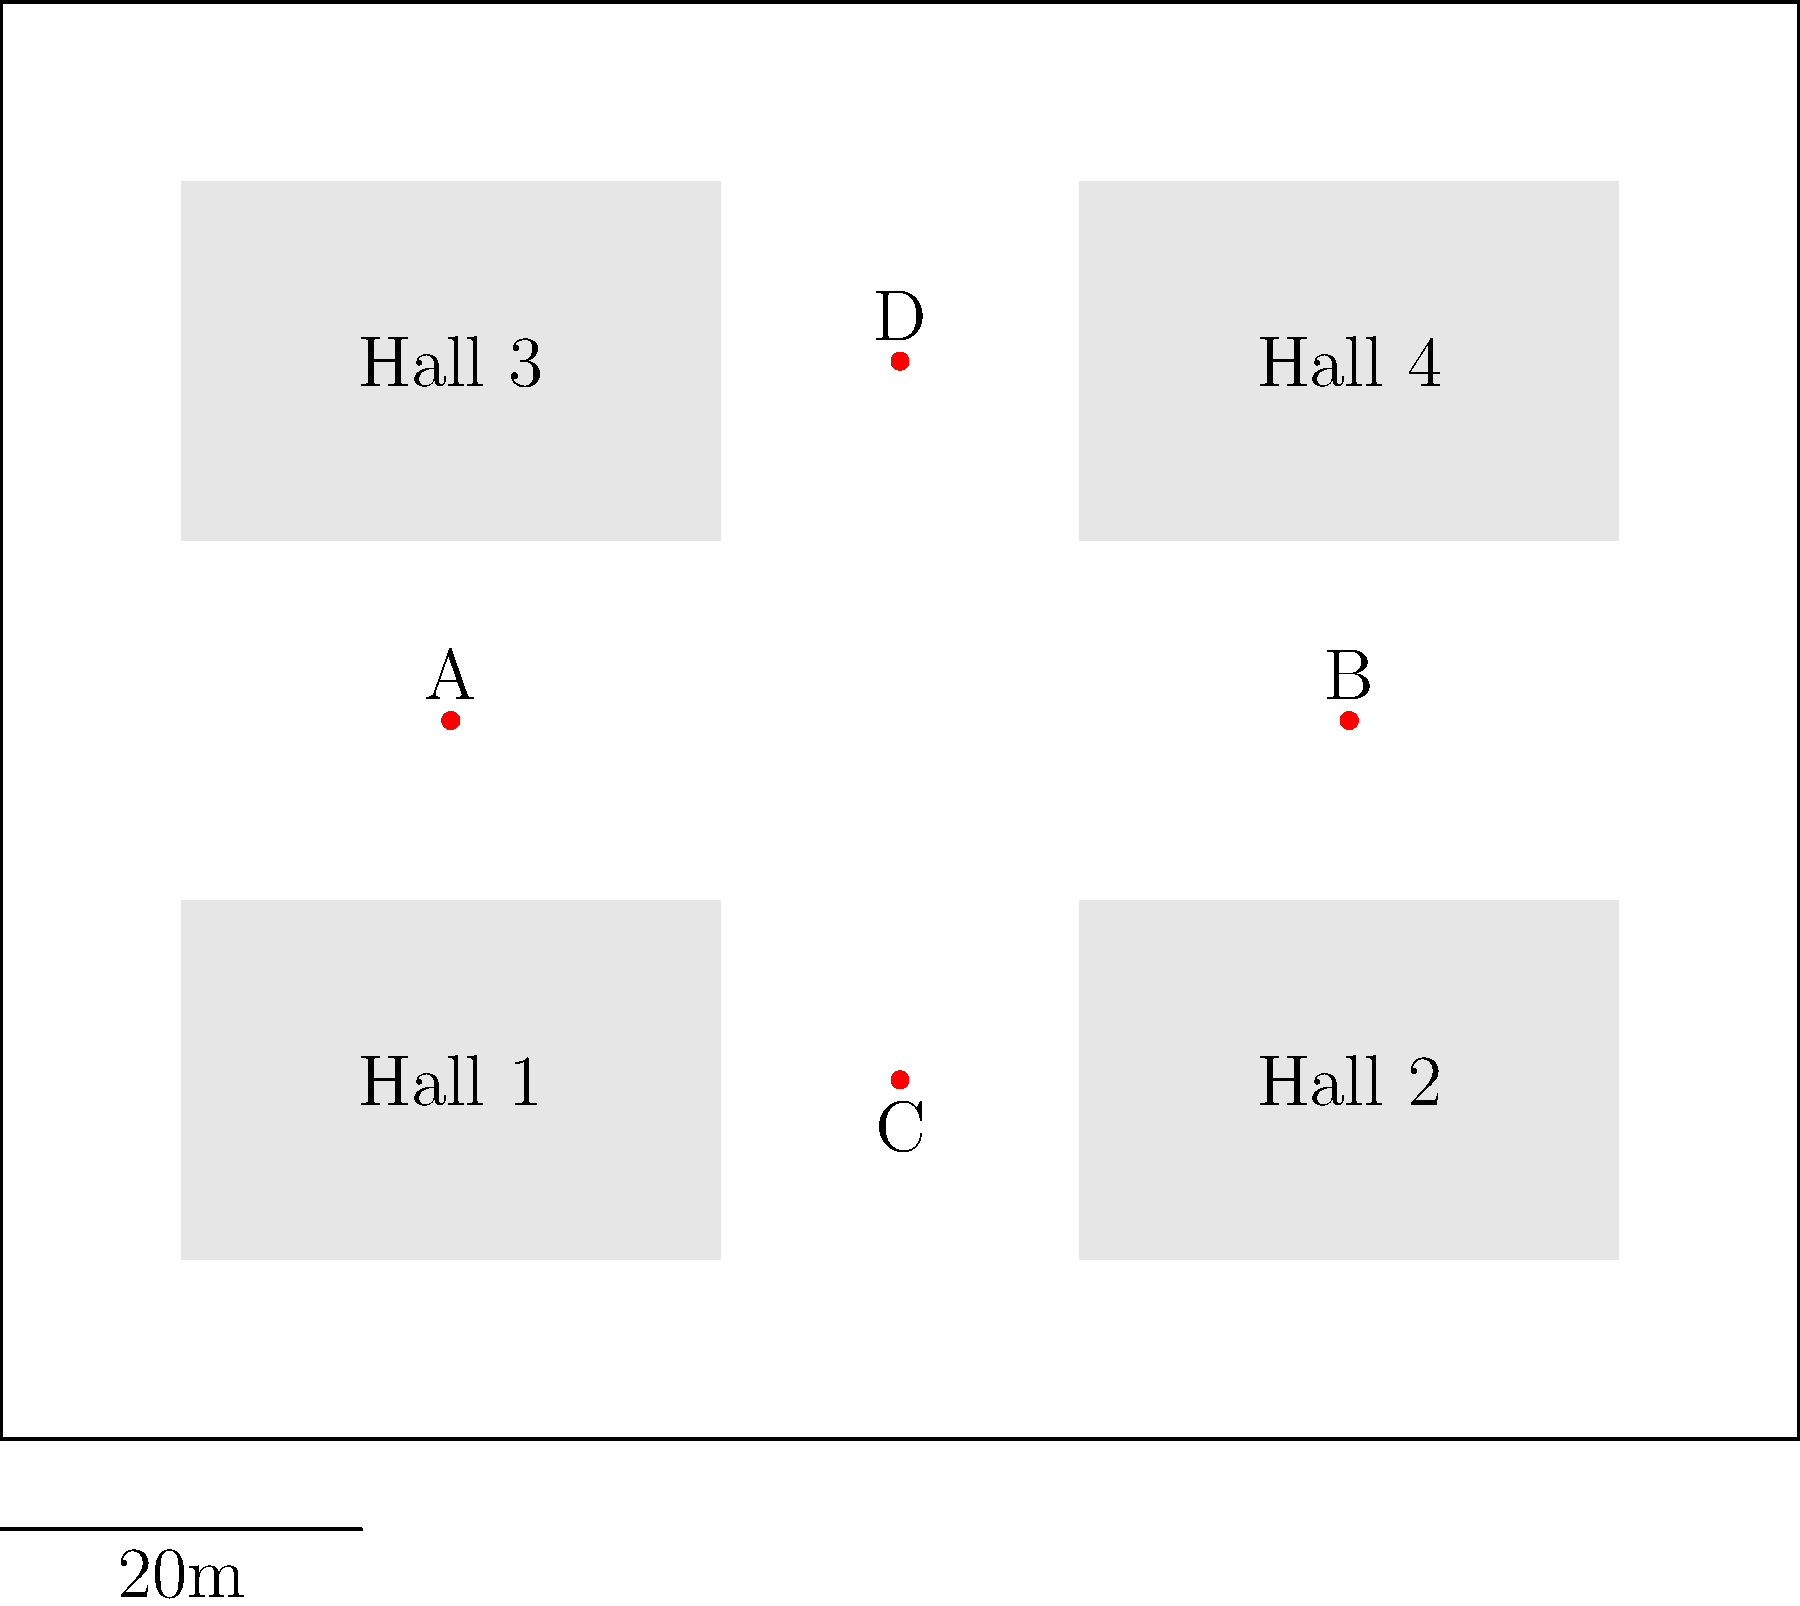Given the conference venue blueprint above, which combination of two refreshment station locations (A, B, C, or D) would provide the most optimal coverage for all four lecture halls while minimizing congestion in the central area? To determine the optimal positioning of refreshment stations, we need to consider several factors:

1. Coverage: The stations should be easily accessible from all four lecture halls.
2. Congestion: We want to minimize crowding in the central area.
3. Distance: The stations should be spread out to cover more area.

Let's analyze each combination:

1. A and B: These are both in the center, which would cause congestion.
2. A and C: This covers the left and bottom areas but leaves the top-right isolated.
3. A and D: This provides good vertical coverage but may cause congestion on the left side.
4. B and C: This provides good diagonal coverage and spreads out the stations.
5. B and D: This covers the right and top areas but leaves the bottom-left isolated.
6. C and D: These are both on the center line, which could cause congestion.

The optimal choice is B and C because:
- They provide diagonal coverage, ensuring all halls have a nearby station.
- They are spread out, minimizing congestion in the central area.
- They allow for easy access from all four halls without creating bottlenecks.

This arrangement ensures that attendees from Hall 1 and Hall 3 can easily access station C, while those from Hall 2 and Hall 4 can use station B. The diagonal placement also encourages movement and networking throughout the venue.
Answer: B and C 